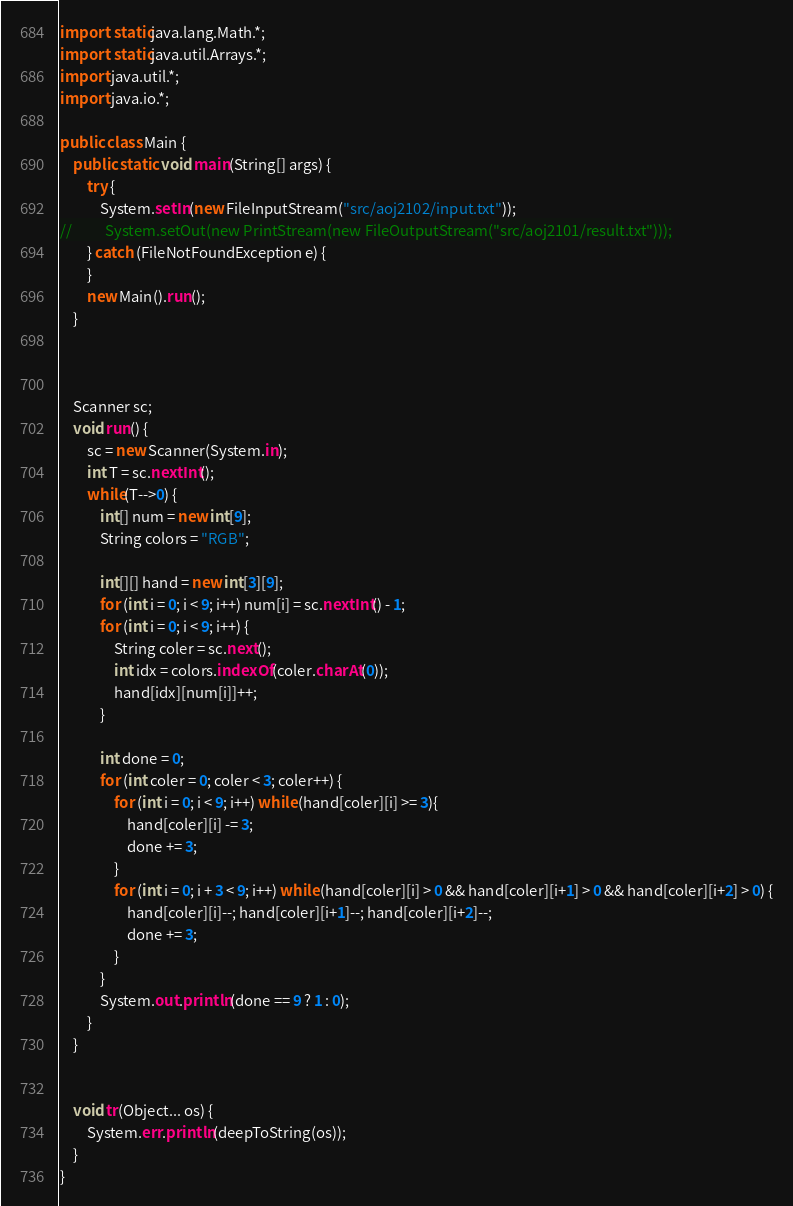<code> <loc_0><loc_0><loc_500><loc_500><_Java_>import static java.lang.Math.*;
import static java.util.Arrays.*;
import java.util.*;
import java.io.*;

public class Main {
	public static void main(String[] args) {
		try {
			System.setIn(new FileInputStream("src/aoj2102/input.txt"));
//			System.setOut(new PrintStream(new FileOutputStream("src/aoj2101/result.txt")));
		} catch (FileNotFoundException e) {
		}
		new Main().run();
	}



	Scanner sc;
	void run() {
		sc = new Scanner(System.in);
		int T = sc.nextInt();
		while(T-->0) {
			int[] num = new int[9];
			String colors = "RGB";

			int[][] hand = new int[3][9];
			for (int i = 0; i < 9; i++) num[i] = sc.nextInt() - 1;
			for (int i = 0; i < 9; i++) {
				String coler = sc.next();
				int idx = colors.indexOf(coler.charAt(0));
				hand[idx][num[i]]++;
			}

			int done = 0;
			for (int coler = 0; coler < 3; coler++) {
				for (int i = 0; i < 9; i++) while (hand[coler][i] >= 3){
					hand[coler][i] -= 3;
					done += 3;
				}
				for (int i = 0; i + 3 < 9; i++) while (hand[coler][i] > 0 && hand[coler][i+1] > 0 && hand[coler][i+2] > 0) {
					hand[coler][i]--; hand[coler][i+1]--; hand[coler][i+2]--;
					done += 3;
				}
			}
			System.out.println(done == 9 ? 1 : 0);
		}
	}


	void tr(Object... os) {
		System.err.println(deepToString(os));
	}
}</code> 